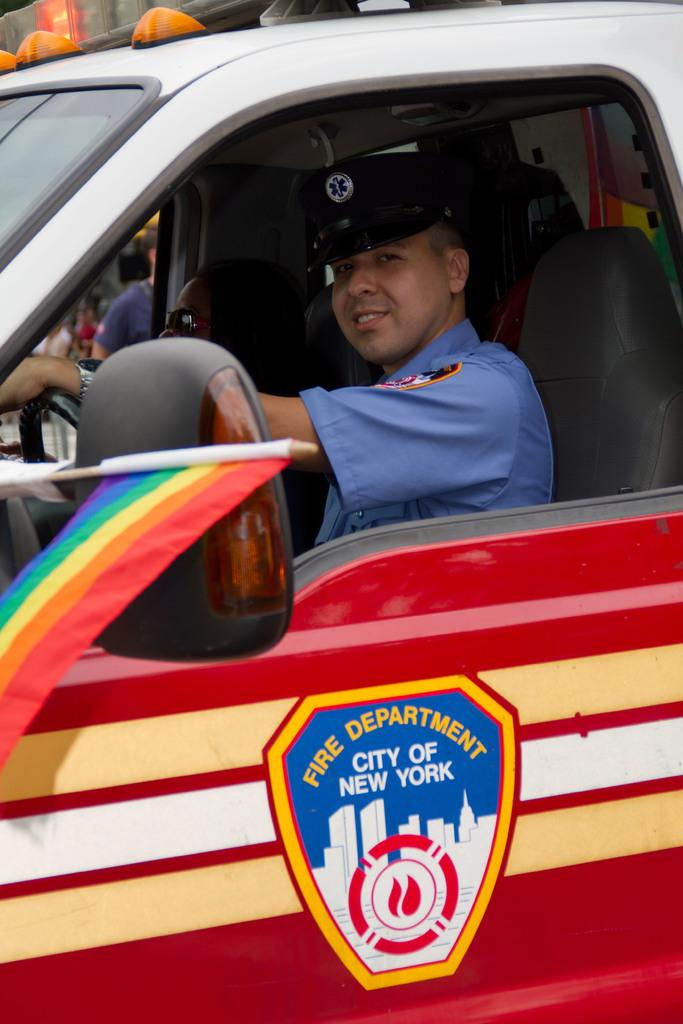Who is in the image? There is a man in the image. What is the man doing in the image? The man is driving a car in the image. What can be seen on the car? The car has "Fire Department City of New York" written on it. What type of canvas is visible in the image? There is no canvas present in the image. Is the man writing in a notebook while driving in the image? The image does not show the man writing in a notebook; he is driving a car. 